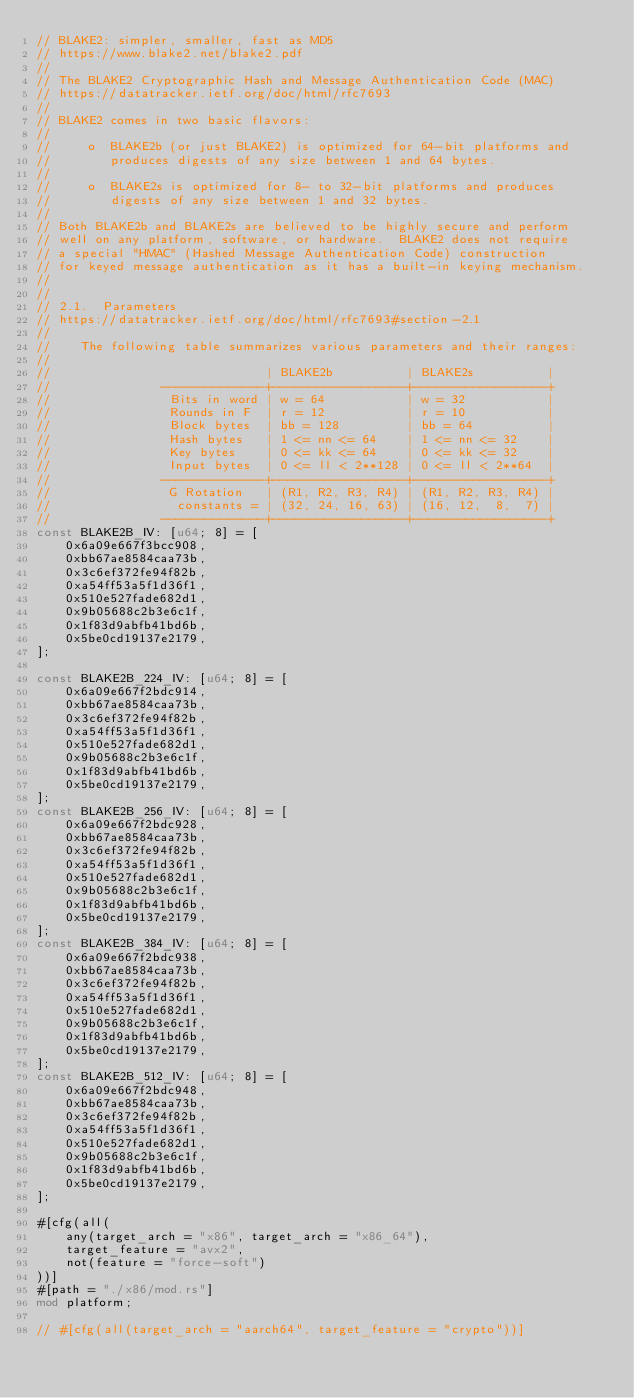<code> <loc_0><loc_0><loc_500><loc_500><_Rust_>// BLAKE2: simpler, smaller, fast as MD5
// https://www.blake2.net/blake2.pdf
//
// The BLAKE2 Cryptographic Hash and Message Authentication Code (MAC)
// https://datatracker.ietf.org/doc/html/rfc7693
//
// BLAKE2 comes in two basic flavors:
//
//     o  BLAKE2b (or just BLAKE2) is optimized for 64-bit platforms and
//        produces digests of any size between 1 and 64 bytes.
//
//     o  BLAKE2s is optimized for 8- to 32-bit platforms and produces
//        digests of any size between 1 and 32 bytes.
//
// Both BLAKE2b and BLAKE2s are believed to be highly secure and perform
// well on any platform, software, or hardware.  BLAKE2 does not require
// a special "HMAC" (Hashed Message Authentication Code) construction
// for keyed message authentication as it has a built-in keying mechanism.
//
//
// 2.1.  Parameters
// https://datatracker.ietf.org/doc/html/rfc7693#section-2.1
//
//    The following table summarizes various parameters and their ranges:
//
//                             | BLAKE2b          | BLAKE2s          |
//               --------------+------------------+------------------+
//                Bits in word | w = 64           | w = 32           |
//                Rounds in F  | r = 12           | r = 10           |
//                Block bytes  | bb = 128         | bb = 64          |
//                Hash bytes   | 1 <= nn <= 64    | 1 <= nn <= 32    |
//                Key bytes    | 0 <= kk <= 64    | 0 <= kk <= 32    |
//                Input bytes  | 0 <= ll < 2**128 | 0 <= ll < 2**64  |
//               --------------+------------------+------------------+
//                G Rotation   | (R1, R2, R3, R4) | (R1, R2, R3, R4) |
//                 constants = | (32, 24, 16, 63) | (16, 12,  8,  7) |
//               --------------+------------------+------------------+
const BLAKE2B_IV: [u64; 8] = [
    0x6a09e667f3bcc908,
    0xbb67ae8584caa73b,
    0x3c6ef372fe94f82b,
    0xa54ff53a5f1d36f1,
    0x510e527fade682d1,
    0x9b05688c2b3e6c1f,
    0x1f83d9abfb41bd6b,
    0x5be0cd19137e2179,
];

const BLAKE2B_224_IV: [u64; 8] = [
    0x6a09e667f2bdc914,
    0xbb67ae8584caa73b,
    0x3c6ef372fe94f82b,
    0xa54ff53a5f1d36f1,
    0x510e527fade682d1,
    0x9b05688c2b3e6c1f,
    0x1f83d9abfb41bd6b,
    0x5be0cd19137e2179,
];
const BLAKE2B_256_IV: [u64; 8] = [
    0x6a09e667f2bdc928,
    0xbb67ae8584caa73b,
    0x3c6ef372fe94f82b,
    0xa54ff53a5f1d36f1,
    0x510e527fade682d1,
    0x9b05688c2b3e6c1f,
    0x1f83d9abfb41bd6b,
    0x5be0cd19137e2179,
];
const BLAKE2B_384_IV: [u64; 8] = [
    0x6a09e667f2bdc938,
    0xbb67ae8584caa73b,
    0x3c6ef372fe94f82b,
    0xa54ff53a5f1d36f1,
    0x510e527fade682d1,
    0x9b05688c2b3e6c1f,
    0x1f83d9abfb41bd6b,
    0x5be0cd19137e2179,
];
const BLAKE2B_512_IV: [u64; 8] = [
    0x6a09e667f2bdc948,
    0xbb67ae8584caa73b,
    0x3c6ef372fe94f82b,
    0xa54ff53a5f1d36f1,
    0x510e527fade682d1,
    0x9b05688c2b3e6c1f,
    0x1f83d9abfb41bd6b,
    0x5be0cd19137e2179,
];

#[cfg(all(
    any(target_arch = "x86", target_arch = "x86_64"),
    target_feature = "avx2",
    not(feature = "force-soft")
))]
#[path = "./x86/mod.rs"]
mod platform;

// #[cfg(all(target_arch = "aarch64", target_feature = "crypto"))]</code> 